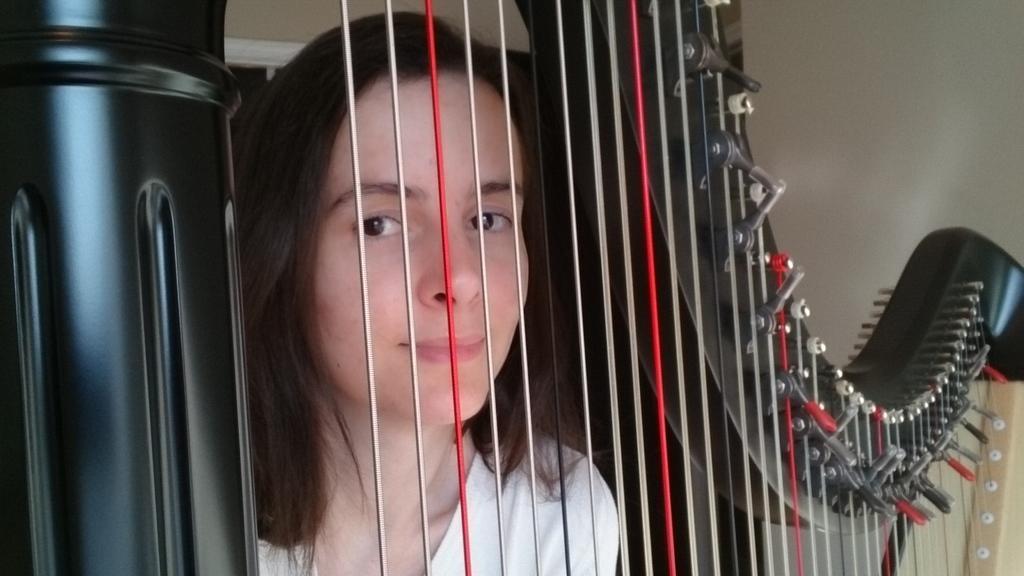Describe this image in one or two sentences. In this picture, it seems like a musical instrument in the foreground and a woman standing behind it. 